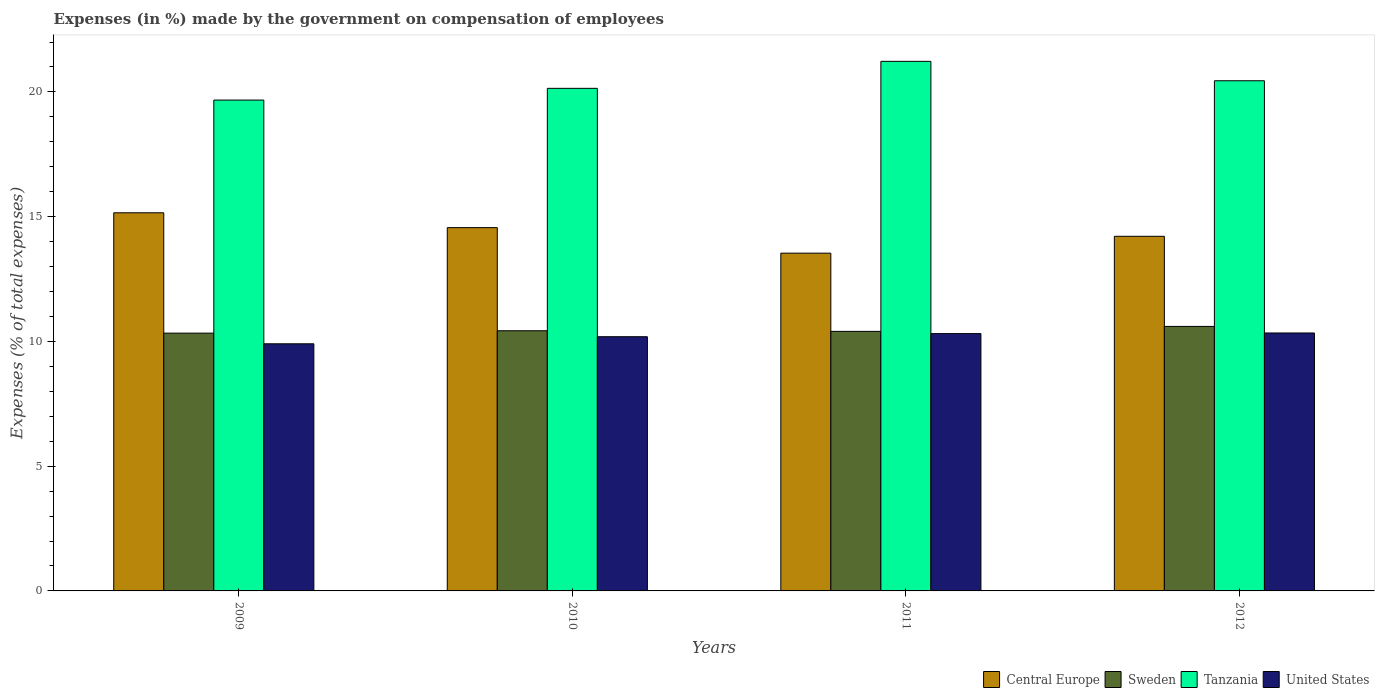How many groups of bars are there?
Make the answer very short. 4. How many bars are there on the 2nd tick from the left?
Provide a short and direct response. 4. How many bars are there on the 1st tick from the right?
Provide a short and direct response. 4. What is the label of the 4th group of bars from the left?
Provide a short and direct response. 2012. In how many cases, is the number of bars for a given year not equal to the number of legend labels?
Offer a terse response. 0. What is the percentage of expenses made by the government on compensation of employees in United States in 2009?
Your answer should be very brief. 9.91. Across all years, what is the maximum percentage of expenses made by the government on compensation of employees in United States?
Provide a succinct answer. 10.34. Across all years, what is the minimum percentage of expenses made by the government on compensation of employees in Sweden?
Your response must be concise. 10.33. In which year was the percentage of expenses made by the government on compensation of employees in Tanzania maximum?
Provide a succinct answer. 2011. In which year was the percentage of expenses made by the government on compensation of employees in Tanzania minimum?
Ensure brevity in your answer.  2009. What is the total percentage of expenses made by the government on compensation of employees in Sweden in the graph?
Your answer should be compact. 41.77. What is the difference between the percentage of expenses made by the government on compensation of employees in Sweden in 2009 and that in 2012?
Offer a terse response. -0.27. What is the difference between the percentage of expenses made by the government on compensation of employees in Sweden in 2011 and the percentage of expenses made by the government on compensation of employees in Tanzania in 2010?
Offer a very short reply. -9.74. What is the average percentage of expenses made by the government on compensation of employees in United States per year?
Your answer should be compact. 10.19. In the year 2012, what is the difference between the percentage of expenses made by the government on compensation of employees in Central Europe and percentage of expenses made by the government on compensation of employees in Sweden?
Your answer should be very brief. 3.61. What is the ratio of the percentage of expenses made by the government on compensation of employees in United States in 2010 to that in 2012?
Your response must be concise. 0.99. Is the difference between the percentage of expenses made by the government on compensation of employees in Central Europe in 2011 and 2012 greater than the difference between the percentage of expenses made by the government on compensation of employees in Sweden in 2011 and 2012?
Your answer should be compact. No. What is the difference between the highest and the second highest percentage of expenses made by the government on compensation of employees in Central Europe?
Keep it short and to the point. 0.59. What is the difference between the highest and the lowest percentage of expenses made by the government on compensation of employees in Sweden?
Make the answer very short. 0.27. Is the sum of the percentage of expenses made by the government on compensation of employees in Central Europe in 2009 and 2012 greater than the maximum percentage of expenses made by the government on compensation of employees in Sweden across all years?
Make the answer very short. Yes. What does the 4th bar from the left in 2012 represents?
Provide a short and direct response. United States. What does the 1st bar from the right in 2010 represents?
Your answer should be compact. United States. How many bars are there?
Keep it short and to the point. 16. Are all the bars in the graph horizontal?
Your answer should be compact. No. What is the difference between two consecutive major ticks on the Y-axis?
Provide a short and direct response. 5. Does the graph contain grids?
Give a very brief answer. No. What is the title of the graph?
Keep it short and to the point. Expenses (in %) made by the government on compensation of employees. Does "Uzbekistan" appear as one of the legend labels in the graph?
Your response must be concise. No. What is the label or title of the X-axis?
Offer a very short reply. Years. What is the label or title of the Y-axis?
Provide a short and direct response. Expenses (% of total expenses). What is the Expenses (% of total expenses) in Central Europe in 2009?
Your response must be concise. 15.16. What is the Expenses (% of total expenses) in Sweden in 2009?
Ensure brevity in your answer.  10.33. What is the Expenses (% of total expenses) in Tanzania in 2009?
Give a very brief answer. 19.67. What is the Expenses (% of total expenses) in United States in 2009?
Ensure brevity in your answer.  9.91. What is the Expenses (% of total expenses) in Central Europe in 2010?
Make the answer very short. 14.56. What is the Expenses (% of total expenses) of Sweden in 2010?
Your answer should be very brief. 10.43. What is the Expenses (% of total expenses) of Tanzania in 2010?
Offer a terse response. 20.14. What is the Expenses (% of total expenses) of United States in 2010?
Provide a succinct answer. 10.19. What is the Expenses (% of total expenses) in Central Europe in 2011?
Ensure brevity in your answer.  13.54. What is the Expenses (% of total expenses) of Sweden in 2011?
Your answer should be compact. 10.4. What is the Expenses (% of total expenses) in Tanzania in 2011?
Offer a very short reply. 21.23. What is the Expenses (% of total expenses) of United States in 2011?
Your response must be concise. 10.31. What is the Expenses (% of total expenses) of Central Europe in 2012?
Provide a short and direct response. 14.21. What is the Expenses (% of total expenses) of Sweden in 2012?
Make the answer very short. 10.6. What is the Expenses (% of total expenses) of Tanzania in 2012?
Provide a short and direct response. 20.45. What is the Expenses (% of total expenses) of United States in 2012?
Offer a terse response. 10.34. Across all years, what is the maximum Expenses (% of total expenses) in Central Europe?
Keep it short and to the point. 15.16. Across all years, what is the maximum Expenses (% of total expenses) of Sweden?
Your answer should be very brief. 10.6. Across all years, what is the maximum Expenses (% of total expenses) in Tanzania?
Provide a short and direct response. 21.23. Across all years, what is the maximum Expenses (% of total expenses) of United States?
Give a very brief answer. 10.34. Across all years, what is the minimum Expenses (% of total expenses) in Central Europe?
Make the answer very short. 13.54. Across all years, what is the minimum Expenses (% of total expenses) of Sweden?
Offer a terse response. 10.33. Across all years, what is the minimum Expenses (% of total expenses) in Tanzania?
Offer a terse response. 19.67. Across all years, what is the minimum Expenses (% of total expenses) in United States?
Give a very brief answer. 9.91. What is the total Expenses (% of total expenses) in Central Europe in the graph?
Offer a terse response. 57.47. What is the total Expenses (% of total expenses) in Sweden in the graph?
Make the answer very short. 41.77. What is the total Expenses (% of total expenses) of Tanzania in the graph?
Provide a succinct answer. 81.49. What is the total Expenses (% of total expenses) of United States in the graph?
Provide a short and direct response. 40.75. What is the difference between the Expenses (% of total expenses) in Central Europe in 2009 and that in 2010?
Provide a succinct answer. 0.59. What is the difference between the Expenses (% of total expenses) of Sweden in 2009 and that in 2010?
Ensure brevity in your answer.  -0.1. What is the difference between the Expenses (% of total expenses) in Tanzania in 2009 and that in 2010?
Provide a short and direct response. -0.47. What is the difference between the Expenses (% of total expenses) of United States in 2009 and that in 2010?
Keep it short and to the point. -0.28. What is the difference between the Expenses (% of total expenses) in Central Europe in 2009 and that in 2011?
Ensure brevity in your answer.  1.62. What is the difference between the Expenses (% of total expenses) in Sweden in 2009 and that in 2011?
Keep it short and to the point. -0.07. What is the difference between the Expenses (% of total expenses) of Tanzania in 2009 and that in 2011?
Your answer should be very brief. -1.55. What is the difference between the Expenses (% of total expenses) in United States in 2009 and that in 2011?
Ensure brevity in your answer.  -0.41. What is the difference between the Expenses (% of total expenses) of Central Europe in 2009 and that in 2012?
Keep it short and to the point. 0.94. What is the difference between the Expenses (% of total expenses) in Sweden in 2009 and that in 2012?
Make the answer very short. -0.27. What is the difference between the Expenses (% of total expenses) of Tanzania in 2009 and that in 2012?
Your response must be concise. -0.77. What is the difference between the Expenses (% of total expenses) of United States in 2009 and that in 2012?
Give a very brief answer. -0.43. What is the difference between the Expenses (% of total expenses) of Central Europe in 2010 and that in 2011?
Offer a terse response. 1.02. What is the difference between the Expenses (% of total expenses) of Sweden in 2010 and that in 2011?
Your response must be concise. 0.02. What is the difference between the Expenses (% of total expenses) of Tanzania in 2010 and that in 2011?
Keep it short and to the point. -1.08. What is the difference between the Expenses (% of total expenses) of United States in 2010 and that in 2011?
Ensure brevity in your answer.  -0.12. What is the difference between the Expenses (% of total expenses) of Central Europe in 2010 and that in 2012?
Your response must be concise. 0.35. What is the difference between the Expenses (% of total expenses) in Sweden in 2010 and that in 2012?
Make the answer very short. -0.17. What is the difference between the Expenses (% of total expenses) in Tanzania in 2010 and that in 2012?
Offer a very short reply. -0.3. What is the difference between the Expenses (% of total expenses) in United States in 2010 and that in 2012?
Your response must be concise. -0.15. What is the difference between the Expenses (% of total expenses) in Central Europe in 2011 and that in 2012?
Offer a very short reply. -0.68. What is the difference between the Expenses (% of total expenses) in Sweden in 2011 and that in 2012?
Offer a terse response. -0.2. What is the difference between the Expenses (% of total expenses) in Tanzania in 2011 and that in 2012?
Your answer should be compact. 0.78. What is the difference between the Expenses (% of total expenses) of United States in 2011 and that in 2012?
Ensure brevity in your answer.  -0.02. What is the difference between the Expenses (% of total expenses) in Central Europe in 2009 and the Expenses (% of total expenses) in Sweden in 2010?
Offer a terse response. 4.73. What is the difference between the Expenses (% of total expenses) in Central Europe in 2009 and the Expenses (% of total expenses) in Tanzania in 2010?
Make the answer very short. -4.99. What is the difference between the Expenses (% of total expenses) in Central Europe in 2009 and the Expenses (% of total expenses) in United States in 2010?
Provide a succinct answer. 4.97. What is the difference between the Expenses (% of total expenses) in Sweden in 2009 and the Expenses (% of total expenses) in Tanzania in 2010?
Keep it short and to the point. -9.81. What is the difference between the Expenses (% of total expenses) in Sweden in 2009 and the Expenses (% of total expenses) in United States in 2010?
Offer a very short reply. 0.14. What is the difference between the Expenses (% of total expenses) in Tanzania in 2009 and the Expenses (% of total expenses) in United States in 2010?
Make the answer very short. 9.48. What is the difference between the Expenses (% of total expenses) in Central Europe in 2009 and the Expenses (% of total expenses) in Sweden in 2011?
Give a very brief answer. 4.75. What is the difference between the Expenses (% of total expenses) in Central Europe in 2009 and the Expenses (% of total expenses) in Tanzania in 2011?
Your answer should be very brief. -6.07. What is the difference between the Expenses (% of total expenses) of Central Europe in 2009 and the Expenses (% of total expenses) of United States in 2011?
Your response must be concise. 4.84. What is the difference between the Expenses (% of total expenses) of Sweden in 2009 and the Expenses (% of total expenses) of Tanzania in 2011?
Your answer should be very brief. -10.89. What is the difference between the Expenses (% of total expenses) of Sweden in 2009 and the Expenses (% of total expenses) of United States in 2011?
Offer a very short reply. 0.02. What is the difference between the Expenses (% of total expenses) of Tanzania in 2009 and the Expenses (% of total expenses) of United States in 2011?
Give a very brief answer. 9.36. What is the difference between the Expenses (% of total expenses) of Central Europe in 2009 and the Expenses (% of total expenses) of Sweden in 2012?
Make the answer very short. 4.55. What is the difference between the Expenses (% of total expenses) of Central Europe in 2009 and the Expenses (% of total expenses) of Tanzania in 2012?
Give a very brief answer. -5.29. What is the difference between the Expenses (% of total expenses) in Central Europe in 2009 and the Expenses (% of total expenses) in United States in 2012?
Make the answer very short. 4.82. What is the difference between the Expenses (% of total expenses) in Sweden in 2009 and the Expenses (% of total expenses) in Tanzania in 2012?
Make the answer very short. -10.12. What is the difference between the Expenses (% of total expenses) in Sweden in 2009 and the Expenses (% of total expenses) in United States in 2012?
Your answer should be very brief. -0.01. What is the difference between the Expenses (% of total expenses) of Tanzania in 2009 and the Expenses (% of total expenses) of United States in 2012?
Ensure brevity in your answer.  9.34. What is the difference between the Expenses (% of total expenses) in Central Europe in 2010 and the Expenses (% of total expenses) in Sweden in 2011?
Provide a short and direct response. 4.16. What is the difference between the Expenses (% of total expenses) in Central Europe in 2010 and the Expenses (% of total expenses) in Tanzania in 2011?
Your response must be concise. -6.66. What is the difference between the Expenses (% of total expenses) of Central Europe in 2010 and the Expenses (% of total expenses) of United States in 2011?
Your answer should be very brief. 4.25. What is the difference between the Expenses (% of total expenses) in Sweden in 2010 and the Expenses (% of total expenses) in Tanzania in 2011?
Provide a succinct answer. -10.8. What is the difference between the Expenses (% of total expenses) of Sweden in 2010 and the Expenses (% of total expenses) of United States in 2011?
Keep it short and to the point. 0.11. What is the difference between the Expenses (% of total expenses) in Tanzania in 2010 and the Expenses (% of total expenses) in United States in 2011?
Provide a succinct answer. 9.83. What is the difference between the Expenses (% of total expenses) in Central Europe in 2010 and the Expenses (% of total expenses) in Sweden in 2012?
Ensure brevity in your answer.  3.96. What is the difference between the Expenses (% of total expenses) in Central Europe in 2010 and the Expenses (% of total expenses) in Tanzania in 2012?
Your answer should be very brief. -5.89. What is the difference between the Expenses (% of total expenses) in Central Europe in 2010 and the Expenses (% of total expenses) in United States in 2012?
Your response must be concise. 4.22. What is the difference between the Expenses (% of total expenses) of Sweden in 2010 and the Expenses (% of total expenses) of Tanzania in 2012?
Provide a succinct answer. -10.02. What is the difference between the Expenses (% of total expenses) of Sweden in 2010 and the Expenses (% of total expenses) of United States in 2012?
Your answer should be compact. 0.09. What is the difference between the Expenses (% of total expenses) of Tanzania in 2010 and the Expenses (% of total expenses) of United States in 2012?
Your answer should be compact. 9.81. What is the difference between the Expenses (% of total expenses) in Central Europe in 2011 and the Expenses (% of total expenses) in Sweden in 2012?
Provide a succinct answer. 2.94. What is the difference between the Expenses (% of total expenses) of Central Europe in 2011 and the Expenses (% of total expenses) of Tanzania in 2012?
Give a very brief answer. -6.91. What is the difference between the Expenses (% of total expenses) in Central Europe in 2011 and the Expenses (% of total expenses) in United States in 2012?
Offer a terse response. 3.2. What is the difference between the Expenses (% of total expenses) in Sweden in 2011 and the Expenses (% of total expenses) in Tanzania in 2012?
Ensure brevity in your answer.  -10.04. What is the difference between the Expenses (% of total expenses) in Sweden in 2011 and the Expenses (% of total expenses) in United States in 2012?
Offer a very short reply. 0.06. What is the difference between the Expenses (% of total expenses) of Tanzania in 2011 and the Expenses (% of total expenses) of United States in 2012?
Provide a succinct answer. 10.89. What is the average Expenses (% of total expenses) in Central Europe per year?
Make the answer very short. 14.37. What is the average Expenses (% of total expenses) of Sweden per year?
Make the answer very short. 10.44. What is the average Expenses (% of total expenses) in Tanzania per year?
Keep it short and to the point. 20.37. What is the average Expenses (% of total expenses) of United States per year?
Keep it short and to the point. 10.19. In the year 2009, what is the difference between the Expenses (% of total expenses) in Central Europe and Expenses (% of total expenses) in Sweden?
Your answer should be very brief. 4.82. In the year 2009, what is the difference between the Expenses (% of total expenses) of Central Europe and Expenses (% of total expenses) of Tanzania?
Make the answer very short. -4.52. In the year 2009, what is the difference between the Expenses (% of total expenses) of Central Europe and Expenses (% of total expenses) of United States?
Your answer should be compact. 5.25. In the year 2009, what is the difference between the Expenses (% of total expenses) in Sweden and Expenses (% of total expenses) in Tanzania?
Your answer should be compact. -9.34. In the year 2009, what is the difference between the Expenses (% of total expenses) in Sweden and Expenses (% of total expenses) in United States?
Your answer should be compact. 0.43. In the year 2009, what is the difference between the Expenses (% of total expenses) of Tanzania and Expenses (% of total expenses) of United States?
Provide a succinct answer. 9.77. In the year 2010, what is the difference between the Expenses (% of total expenses) in Central Europe and Expenses (% of total expenses) in Sweden?
Keep it short and to the point. 4.13. In the year 2010, what is the difference between the Expenses (% of total expenses) in Central Europe and Expenses (% of total expenses) in Tanzania?
Provide a succinct answer. -5.58. In the year 2010, what is the difference between the Expenses (% of total expenses) of Central Europe and Expenses (% of total expenses) of United States?
Your answer should be very brief. 4.37. In the year 2010, what is the difference between the Expenses (% of total expenses) in Sweden and Expenses (% of total expenses) in Tanzania?
Give a very brief answer. -9.72. In the year 2010, what is the difference between the Expenses (% of total expenses) of Sweden and Expenses (% of total expenses) of United States?
Your response must be concise. 0.24. In the year 2010, what is the difference between the Expenses (% of total expenses) in Tanzania and Expenses (% of total expenses) in United States?
Offer a terse response. 9.96. In the year 2011, what is the difference between the Expenses (% of total expenses) of Central Europe and Expenses (% of total expenses) of Sweden?
Your answer should be compact. 3.13. In the year 2011, what is the difference between the Expenses (% of total expenses) in Central Europe and Expenses (% of total expenses) in Tanzania?
Your response must be concise. -7.69. In the year 2011, what is the difference between the Expenses (% of total expenses) of Central Europe and Expenses (% of total expenses) of United States?
Give a very brief answer. 3.22. In the year 2011, what is the difference between the Expenses (% of total expenses) in Sweden and Expenses (% of total expenses) in Tanzania?
Your response must be concise. -10.82. In the year 2011, what is the difference between the Expenses (% of total expenses) of Sweden and Expenses (% of total expenses) of United States?
Make the answer very short. 0.09. In the year 2011, what is the difference between the Expenses (% of total expenses) in Tanzania and Expenses (% of total expenses) in United States?
Offer a terse response. 10.91. In the year 2012, what is the difference between the Expenses (% of total expenses) of Central Europe and Expenses (% of total expenses) of Sweden?
Offer a very short reply. 3.61. In the year 2012, what is the difference between the Expenses (% of total expenses) in Central Europe and Expenses (% of total expenses) in Tanzania?
Offer a terse response. -6.23. In the year 2012, what is the difference between the Expenses (% of total expenses) in Central Europe and Expenses (% of total expenses) in United States?
Your answer should be compact. 3.88. In the year 2012, what is the difference between the Expenses (% of total expenses) in Sweden and Expenses (% of total expenses) in Tanzania?
Make the answer very short. -9.85. In the year 2012, what is the difference between the Expenses (% of total expenses) of Sweden and Expenses (% of total expenses) of United States?
Your answer should be compact. 0.26. In the year 2012, what is the difference between the Expenses (% of total expenses) in Tanzania and Expenses (% of total expenses) in United States?
Your response must be concise. 10.11. What is the ratio of the Expenses (% of total expenses) in Central Europe in 2009 to that in 2010?
Provide a short and direct response. 1.04. What is the ratio of the Expenses (% of total expenses) of Sweden in 2009 to that in 2010?
Give a very brief answer. 0.99. What is the ratio of the Expenses (% of total expenses) in Tanzania in 2009 to that in 2010?
Keep it short and to the point. 0.98. What is the ratio of the Expenses (% of total expenses) of United States in 2009 to that in 2010?
Offer a terse response. 0.97. What is the ratio of the Expenses (% of total expenses) in Central Europe in 2009 to that in 2011?
Offer a terse response. 1.12. What is the ratio of the Expenses (% of total expenses) of Tanzania in 2009 to that in 2011?
Keep it short and to the point. 0.93. What is the ratio of the Expenses (% of total expenses) of United States in 2009 to that in 2011?
Your answer should be compact. 0.96. What is the ratio of the Expenses (% of total expenses) of Central Europe in 2009 to that in 2012?
Give a very brief answer. 1.07. What is the ratio of the Expenses (% of total expenses) in Sweden in 2009 to that in 2012?
Ensure brevity in your answer.  0.97. What is the ratio of the Expenses (% of total expenses) in Tanzania in 2009 to that in 2012?
Provide a short and direct response. 0.96. What is the ratio of the Expenses (% of total expenses) of United States in 2009 to that in 2012?
Make the answer very short. 0.96. What is the ratio of the Expenses (% of total expenses) of Central Europe in 2010 to that in 2011?
Offer a terse response. 1.08. What is the ratio of the Expenses (% of total expenses) in Sweden in 2010 to that in 2011?
Your response must be concise. 1. What is the ratio of the Expenses (% of total expenses) in Tanzania in 2010 to that in 2011?
Ensure brevity in your answer.  0.95. What is the ratio of the Expenses (% of total expenses) of United States in 2010 to that in 2011?
Provide a succinct answer. 0.99. What is the ratio of the Expenses (% of total expenses) in Central Europe in 2010 to that in 2012?
Ensure brevity in your answer.  1.02. What is the ratio of the Expenses (% of total expenses) of Sweden in 2010 to that in 2012?
Your answer should be compact. 0.98. What is the ratio of the Expenses (% of total expenses) of Tanzania in 2010 to that in 2012?
Offer a very short reply. 0.99. What is the ratio of the Expenses (% of total expenses) in United States in 2010 to that in 2012?
Your answer should be very brief. 0.99. What is the ratio of the Expenses (% of total expenses) in Central Europe in 2011 to that in 2012?
Offer a terse response. 0.95. What is the ratio of the Expenses (% of total expenses) in Sweden in 2011 to that in 2012?
Your answer should be very brief. 0.98. What is the ratio of the Expenses (% of total expenses) in Tanzania in 2011 to that in 2012?
Your answer should be compact. 1.04. What is the difference between the highest and the second highest Expenses (% of total expenses) of Central Europe?
Ensure brevity in your answer.  0.59. What is the difference between the highest and the second highest Expenses (% of total expenses) of Sweden?
Ensure brevity in your answer.  0.17. What is the difference between the highest and the second highest Expenses (% of total expenses) of Tanzania?
Offer a terse response. 0.78. What is the difference between the highest and the second highest Expenses (% of total expenses) of United States?
Offer a terse response. 0.02. What is the difference between the highest and the lowest Expenses (% of total expenses) in Central Europe?
Offer a terse response. 1.62. What is the difference between the highest and the lowest Expenses (% of total expenses) of Sweden?
Give a very brief answer. 0.27. What is the difference between the highest and the lowest Expenses (% of total expenses) in Tanzania?
Offer a very short reply. 1.55. What is the difference between the highest and the lowest Expenses (% of total expenses) of United States?
Your response must be concise. 0.43. 